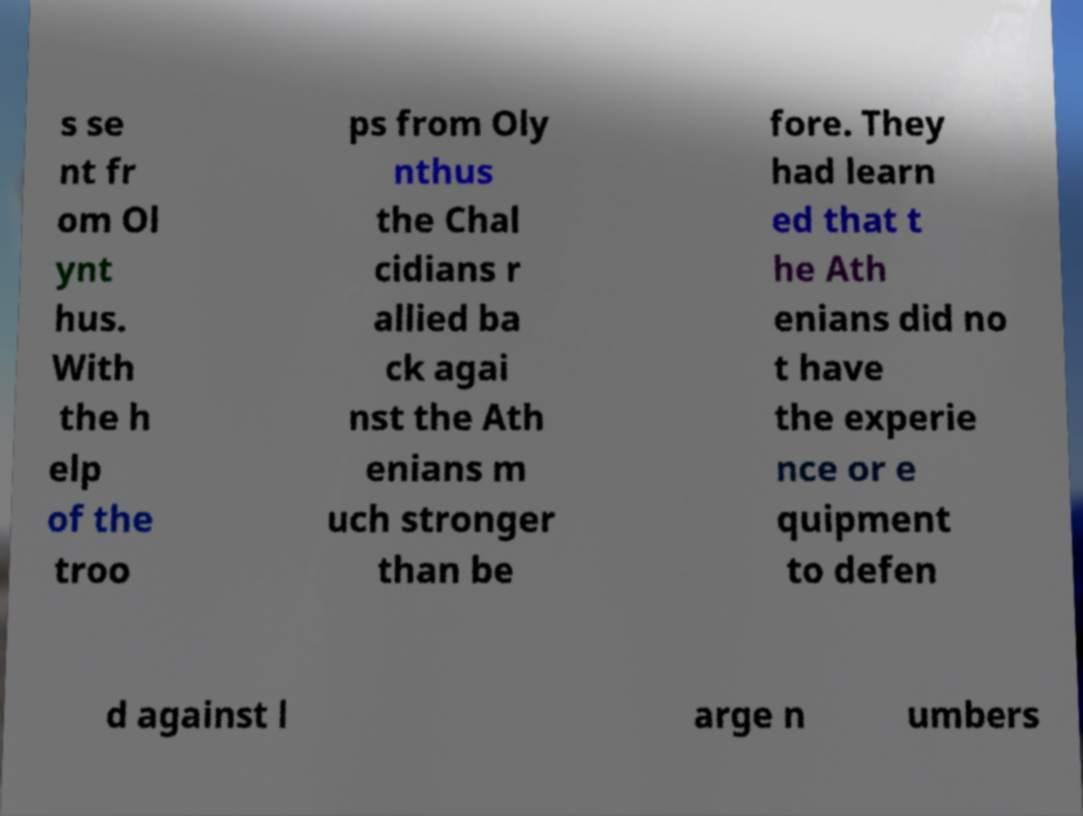Please identify and transcribe the text found in this image. s se nt fr om Ol ynt hus. With the h elp of the troo ps from Oly nthus the Chal cidians r allied ba ck agai nst the Ath enians m uch stronger than be fore. They had learn ed that t he Ath enians did no t have the experie nce or e quipment to defen d against l arge n umbers 